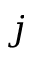Convert formula to latex. <formula><loc_0><loc_0><loc_500><loc_500>j</formula> 